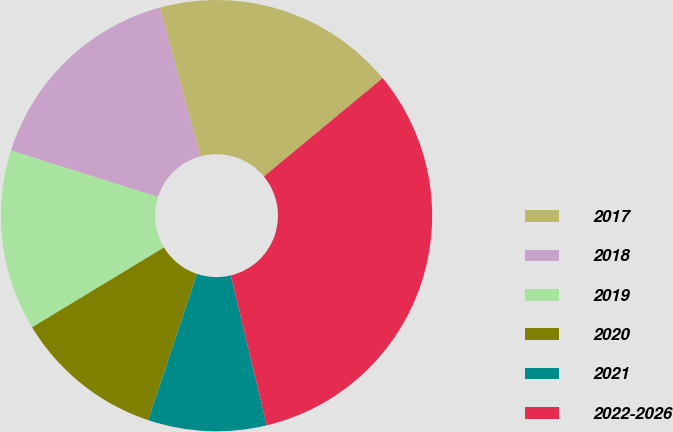Convert chart. <chart><loc_0><loc_0><loc_500><loc_500><pie_chart><fcel>2017<fcel>2018<fcel>2019<fcel>2020<fcel>2021<fcel>2022-2026<nl><fcel>18.23%<fcel>15.89%<fcel>13.55%<fcel>11.21%<fcel>8.87%<fcel>32.27%<nl></chart> 